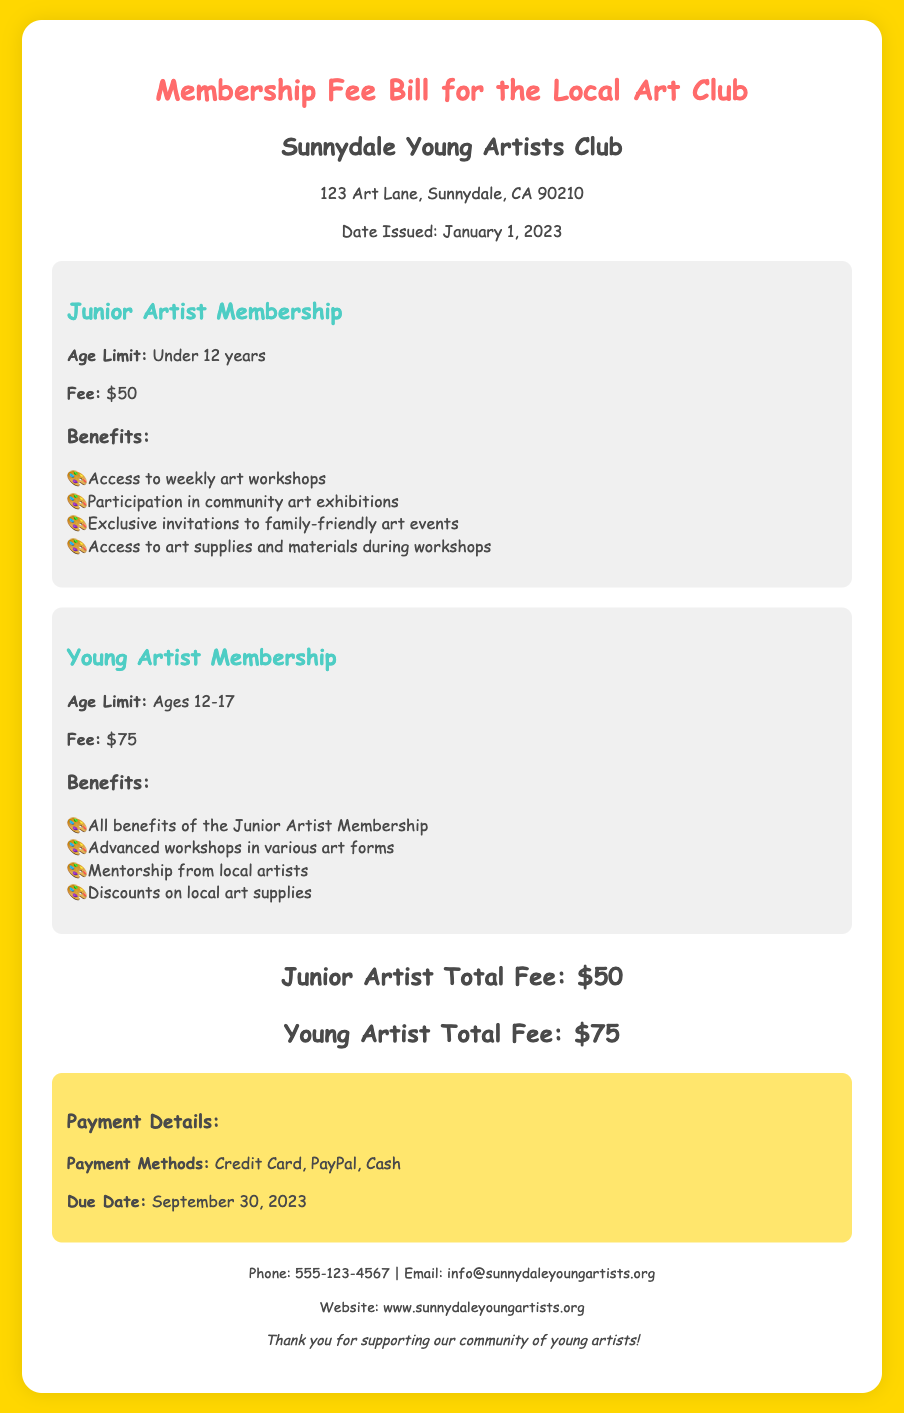What is the total fee for Junior Artist Membership? The total fee for Junior Artist Membership is explicitly stated in the document.
Answer: $50 What is the age limit for Junior Artist Membership? The age limit for Junior Artist Membership is clearly mentioned in the membership detail section.
Answer: Under 12 years What benefits come with Young Artist Membership? The benefits for Young Artist Membership are listed in the benefits section of the membership type.
Answer: All benefits of the Junior Artist Membership, Advanced workshops in various art forms, Mentorship from local artists, Discounts on local art supplies What is the due date for the membership fee payment? The due date is specified in the payment details section of the document.
Answer: September 30, 2023 What is the fee for Young Artist Membership? The fee for Young Artist Membership is noted in the document under the membership type.
Answer: $75 How many weekly art workshops can members access? The document mentions "Access to weekly art workshops" under the benefits for Junior Artist Membership.
Answer: Weekly What is the email address for the Local Art Club? The email address is found in the footer of the document.
Answer: info@sunnydaleyoungartists.org What are the payment methods mentioned in the document? The payment methods are listed in the payment information section.
Answer: Credit Card, PayPal, Cash What type of events do members receive exclusive invitations to? The document states that members get exclusive invitations to family-friendly art events.
Answer: Family-friendly art events 